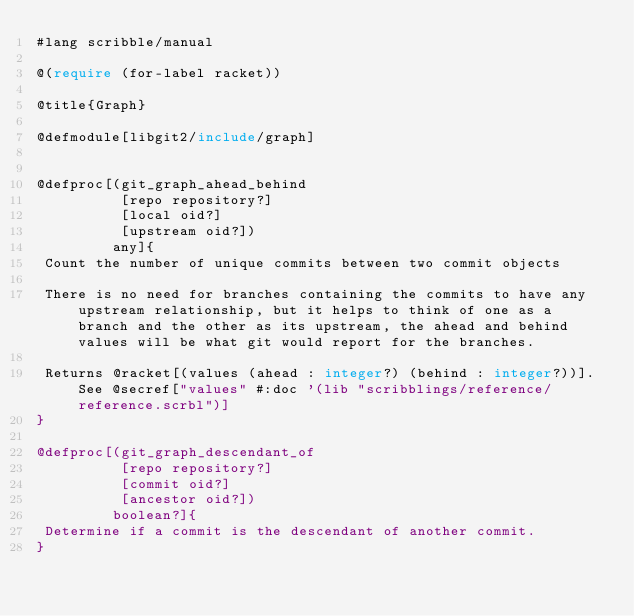<code> <loc_0><loc_0><loc_500><loc_500><_Racket_>#lang scribble/manual

@(require (for-label racket))

@title{Graph}

@defmodule[libgit2/include/graph]


@defproc[(git_graph_ahead_behind
          [repo repository?]
          [local oid?]
          [upstream oid?])
         any]{
 Count the number of unique commits between two commit objects

 There is no need for branches containing the commits to have any upstream relationship, but it helps to think of one as a branch and the other as its upstream, the ahead and behind values will be what git would report for the branches.

 Returns @racket[(values (ahead : integer?) (behind : integer?))]. See @secref["values" #:doc '(lib "scribblings/reference/reference.scrbl")]
}

@defproc[(git_graph_descendant_of
          [repo repository?]
          [commit oid?]
          [ancestor oid?])
         boolean?]{
 Determine if a commit is the descendant of another commit.
}
</code> 